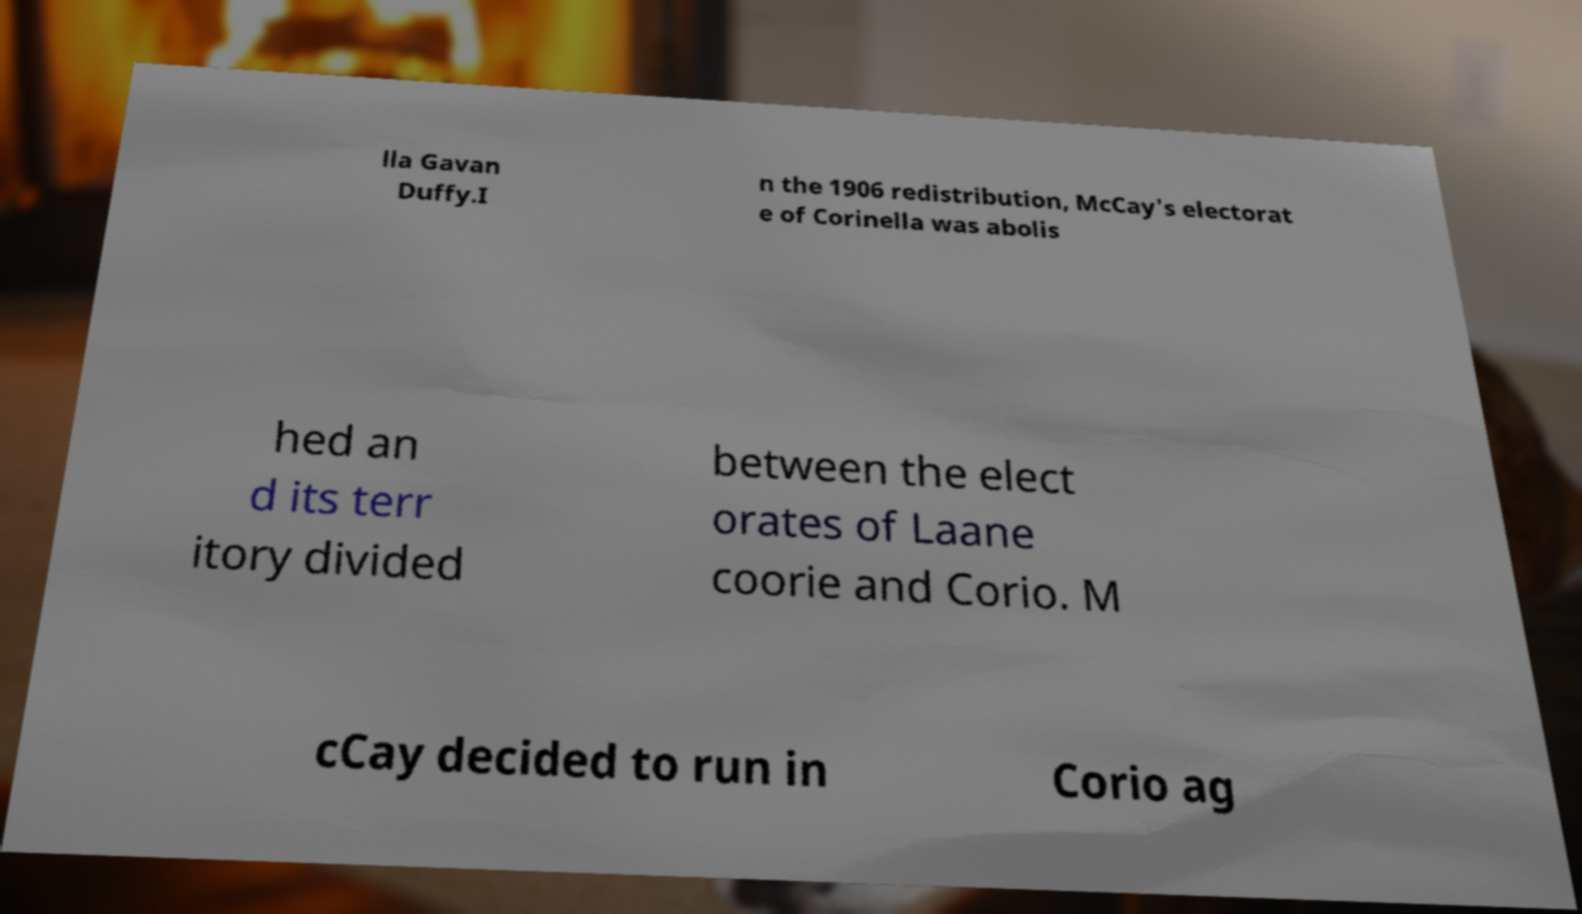Could you assist in decoding the text presented in this image and type it out clearly? lla Gavan Duffy.I n the 1906 redistribution, McCay's electorat e of Corinella was abolis hed an d its terr itory divided between the elect orates of Laane coorie and Corio. M cCay decided to run in Corio ag 